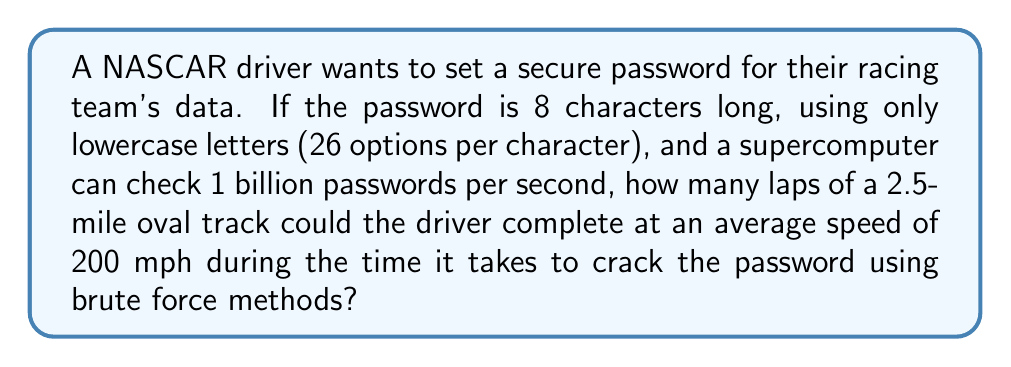Provide a solution to this math problem. Let's break this down step-by-step:

1) First, calculate the total number of possible passwords:
   $$ \text{Total passwords} = 26^8 = 208,827,064,576 $$

2) Calculate the time needed to check all passwords:
   $$ \text{Time (seconds)} = \frac{208,827,064,576}{1,000,000,000} = 208.827064576 \text{ seconds} $$

3) Convert this time to hours:
   $$ \text{Time (hours)} = \frac{208.827064576}{3600} = 0.05800752 \text{ hours} $$

4) Calculate the distance the driver can travel in this time:
   $$ \text{Distance} = 200 \text{ mph} \times 0.05800752 \text{ hours} = 11.6015 \text{ miles} $$

5) Calculate the number of laps:
   $$ \text{Number of laps} = \frac{11.6015 \text{ miles}}{2.5 \text{ miles per lap}} = 4.6406 \text{ laps} $$

Therefore, the driver could complete 4 full laps and be partway through the 5th lap.
Answer: 4 full laps 